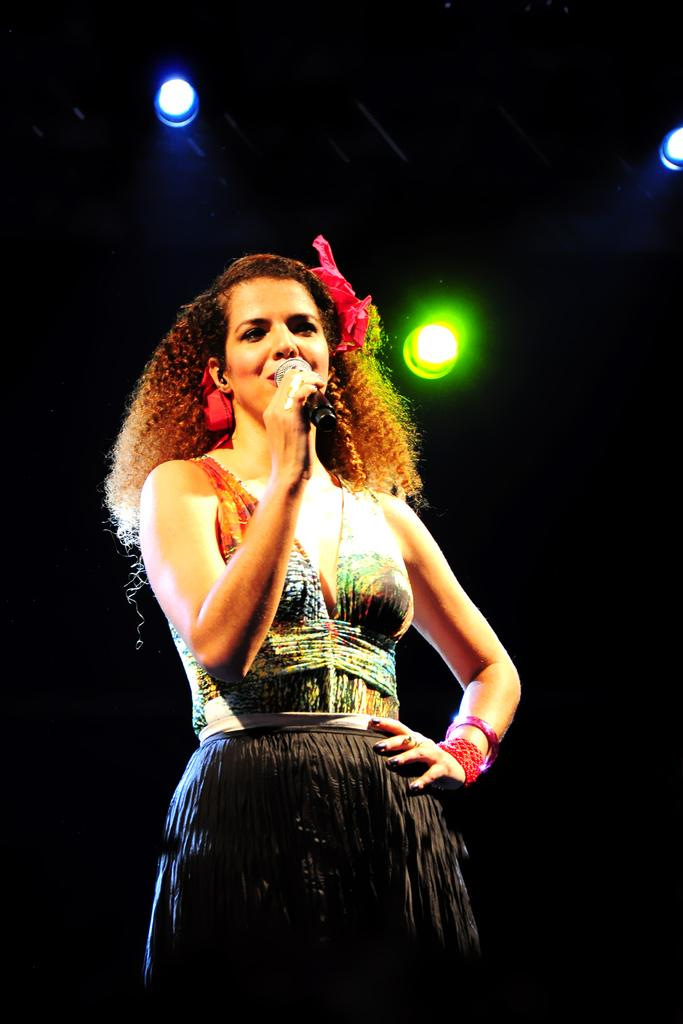What is the main subject of the image? There is a person in the image. What is the person holding in the image? The person is holding a microphone. What can be seen at the top of the image? There are lights visible at the top of the image. How many sisters does the person in the image have? There is no information about the person's sisters in the image, so we cannot determine the number of sisters they have. 